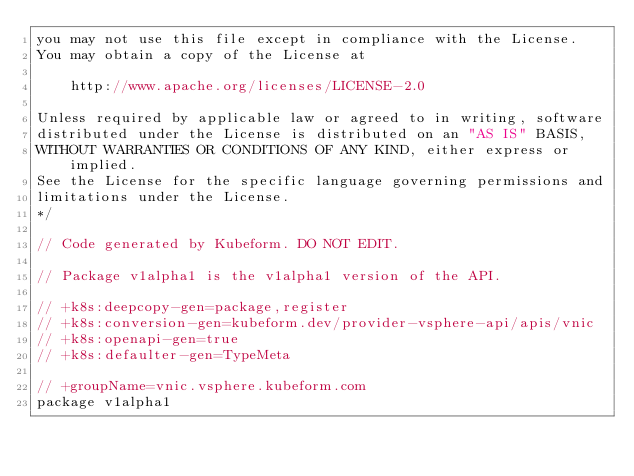Convert code to text. <code><loc_0><loc_0><loc_500><loc_500><_Go_>you may not use this file except in compliance with the License.
You may obtain a copy of the License at

    http://www.apache.org/licenses/LICENSE-2.0

Unless required by applicable law or agreed to in writing, software
distributed under the License is distributed on an "AS IS" BASIS,
WITHOUT WARRANTIES OR CONDITIONS OF ANY KIND, either express or implied.
See the License for the specific language governing permissions and
limitations under the License.
*/

// Code generated by Kubeform. DO NOT EDIT.

// Package v1alpha1 is the v1alpha1 version of the API.

// +k8s:deepcopy-gen=package,register
// +k8s:conversion-gen=kubeform.dev/provider-vsphere-api/apis/vnic
// +k8s:openapi-gen=true
// +k8s:defaulter-gen=TypeMeta

// +groupName=vnic.vsphere.kubeform.com
package v1alpha1
</code> 